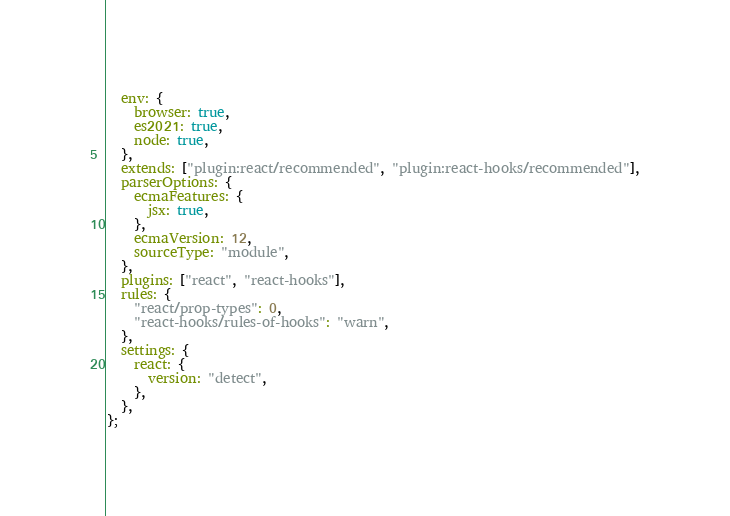Convert code to text. <code><loc_0><loc_0><loc_500><loc_500><_JavaScript_>  env: {
    browser: true,
    es2021: true,
    node: true,
  },
  extends: ["plugin:react/recommended", "plugin:react-hooks/recommended"],
  parserOptions: {
    ecmaFeatures: {
      jsx: true,
    },
    ecmaVersion: 12,
    sourceType: "module",
  },
  plugins: ["react", "react-hooks"],
  rules: {
    "react/prop-types": 0,
    "react-hooks/rules-of-hooks": "warn",
  },
  settings: {
    react: {
      version: "detect",
    },
  },
};
</code> 